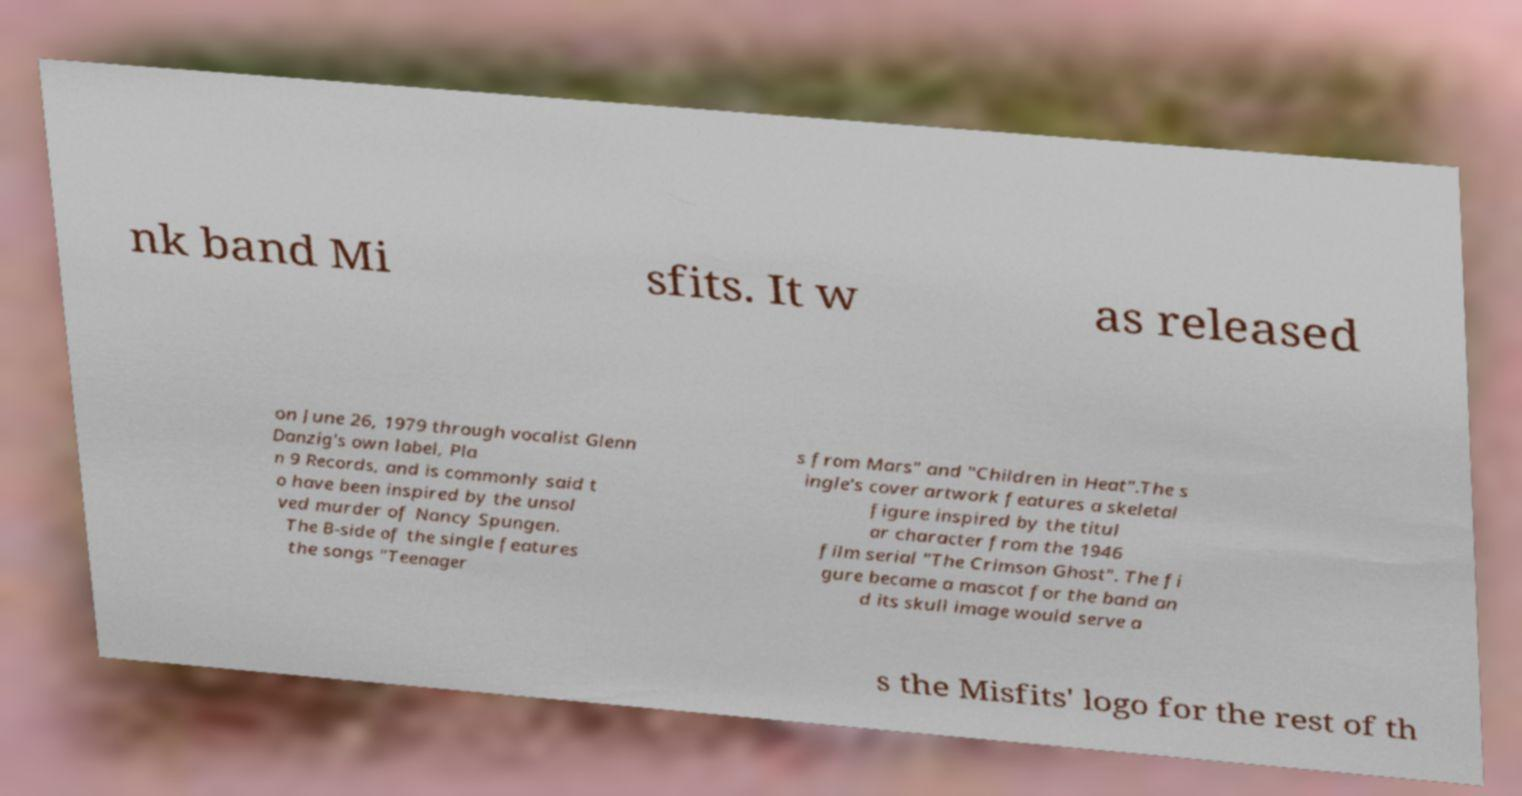Can you accurately transcribe the text from the provided image for me? nk band Mi sfits. It w as released on June 26, 1979 through vocalist Glenn Danzig's own label, Pla n 9 Records, and is commonly said t o have been inspired by the unsol ved murder of Nancy Spungen. The B-side of the single features the songs "Teenager s from Mars" and "Children in Heat".The s ingle's cover artwork features a skeletal figure inspired by the titul ar character from the 1946 film serial "The Crimson Ghost". The fi gure became a mascot for the band an d its skull image would serve a s the Misfits' logo for the rest of th 